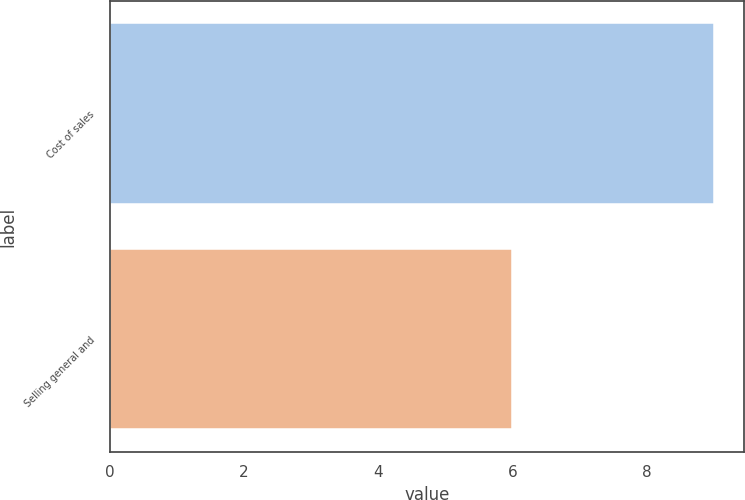Convert chart to OTSL. <chart><loc_0><loc_0><loc_500><loc_500><bar_chart><fcel>Cost of sales<fcel>Selling general and<nl><fcel>9<fcel>6<nl></chart> 